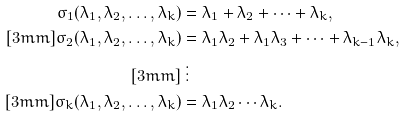<formula> <loc_0><loc_0><loc_500><loc_500>\sigma _ { 1 } ( \lambda _ { 1 } , \lambda _ { 2 } , \dots , \lambda _ { k } ) & = \lambda _ { 1 } + \lambda _ { 2 } + \dots + \lambda _ { k } , \\ [ 3 m m ] \sigma _ { 2 } ( \lambda _ { 1 } , \lambda _ { 2 } , \dots , \lambda _ { k } ) & = \lambda _ { 1 } \lambda _ { 2 } + \lambda _ { 1 } \lambda _ { 3 } + \dots + \lambda _ { k - 1 } \lambda _ { k } , \\ [ 3 m m ] & \, \vdots \\ [ 3 m m ] \sigma _ { k } ( \lambda _ { 1 } , \lambda _ { 2 } , \dots , \lambda _ { k } ) & = \lambda _ { 1 } \lambda _ { 2 } \cdots \lambda _ { k } .</formula> 